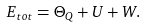<formula> <loc_0><loc_0><loc_500><loc_500>E _ { t o t } = \Theta _ { Q } + U + W .</formula> 